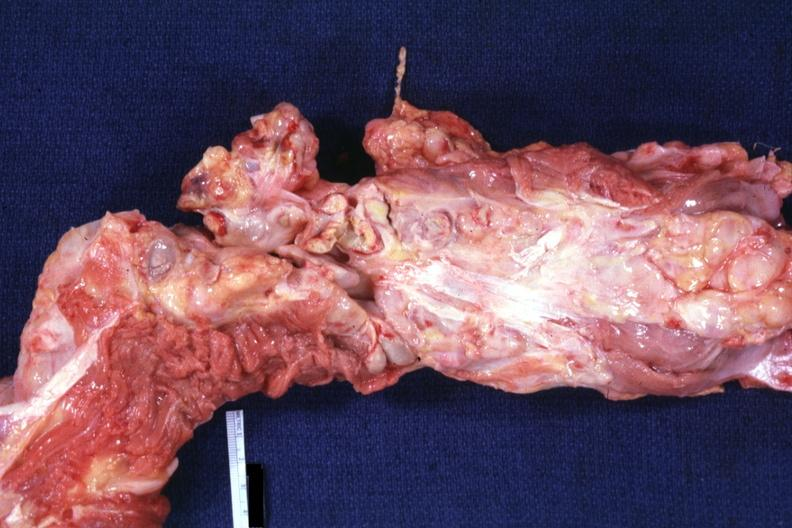what is present?
Answer the question using a single word or phrase. Hodgkins disease 